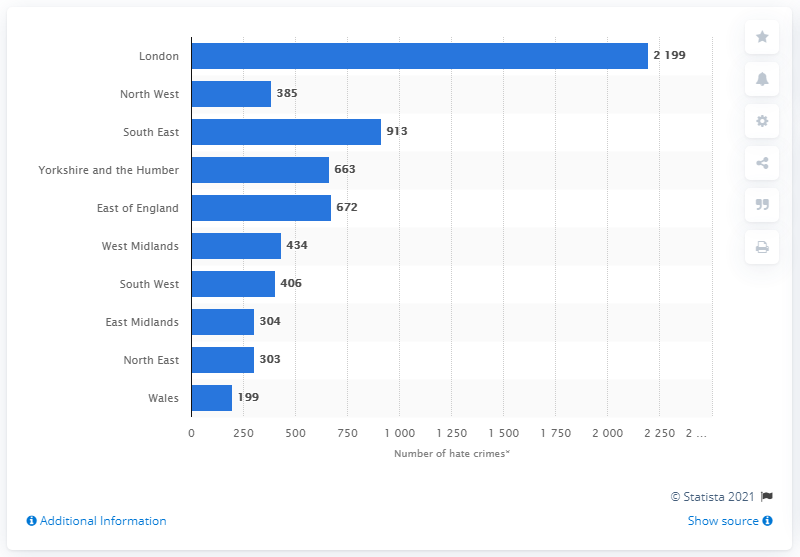Draw attention to some important aspects in this diagram. As of 199.., the number of racially motivated hate crimes recorded in Wales stands at [insert number]. There were 2,199 religiously motivated hate crimes in London during the 2019/2020 reporting period. In London, there were 2199 reported incidents of racially motivated hate crimes in 2020. Six bars have a value below 500. 